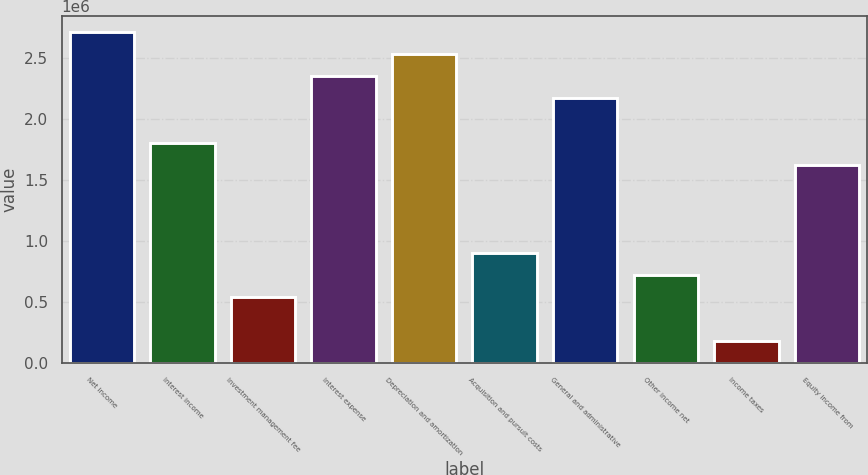Convert chart to OTSL. <chart><loc_0><loc_0><loc_500><loc_500><bar_chart><fcel>Net income<fcel>Interest income<fcel>Investment management fee<fcel>Interest expense<fcel>Depreciation and amortization<fcel>Acquisition and pursuit costs<fcel>General and administrative<fcel>Other income net<fcel>Income taxes<fcel>Equity income from<nl><fcel>2.70806e+06<fcel>1.80538e+06<fcel>541620<fcel>2.34699e+06<fcel>2.52752e+06<fcel>902694<fcel>2.16645e+06<fcel>722157<fcel>180548<fcel>1.62484e+06<nl></chart> 